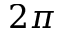<formula> <loc_0><loc_0><loc_500><loc_500>2 \pi</formula> 